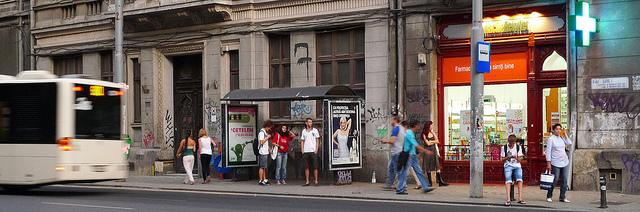What type of food does the store on the right sell?
Keep it brief. Groceries. Is the "+" sign lit up?
Keep it brief. Yes. How many non-red buses are in the street?
Be succinct. 1. How many people are waiting at the bus station?
Write a very short answer. 3. What color is the bus?
Concise answer only. White. Are these streets safe?
Answer briefly. Yes. What is painted on the wall on the right?
Be succinct. Graffiti. How many people do you see?
Write a very short answer. 11. What items are behind the glass window?
Keep it brief. Products. 